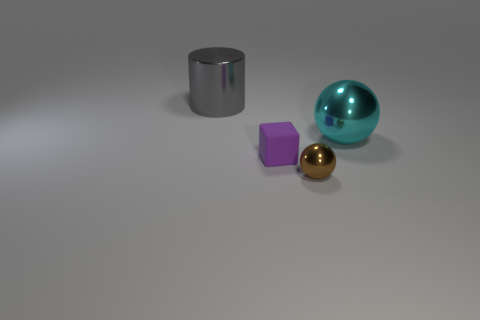What number of large metal cylinders are right of the tiny rubber thing?
Make the answer very short. 0. How many tiny brown balls have the same material as the big gray cylinder?
Your response must be concise. 1. Is the material of the large object that is to the right of the small brown metal sphere the same as the brown ball?
Ensure brevity in your answer.  Yes. Is there a gray object?
Provide a short and direct response. Yes. There is a metallic object that is behind the tiny brown metallic sphere and on the left side of the cyan shiny ball; what is its size?
Give a very brief answer. Large. Is the number of tiny brown objects in front of the small metal sphere greater than the number of metal balls that are to the right of the gray shiny object?
Make the answer very short. No. The tiny matte object has what color?
Your response must be concise. Purple. What color is the thing that is both behind the tiny purple matte object and to the left of the brown object?
Keep it short and to the point. Gray. There is a big shiny object that is on the left side of the large object in front of the thing that is behind the big cyan metal ball; what color is it?
Provide a short and direct response. Gray. There is a matte block that is the same size as the brown shiny sphere; what is its color?
Your response must be concise. Purple. 